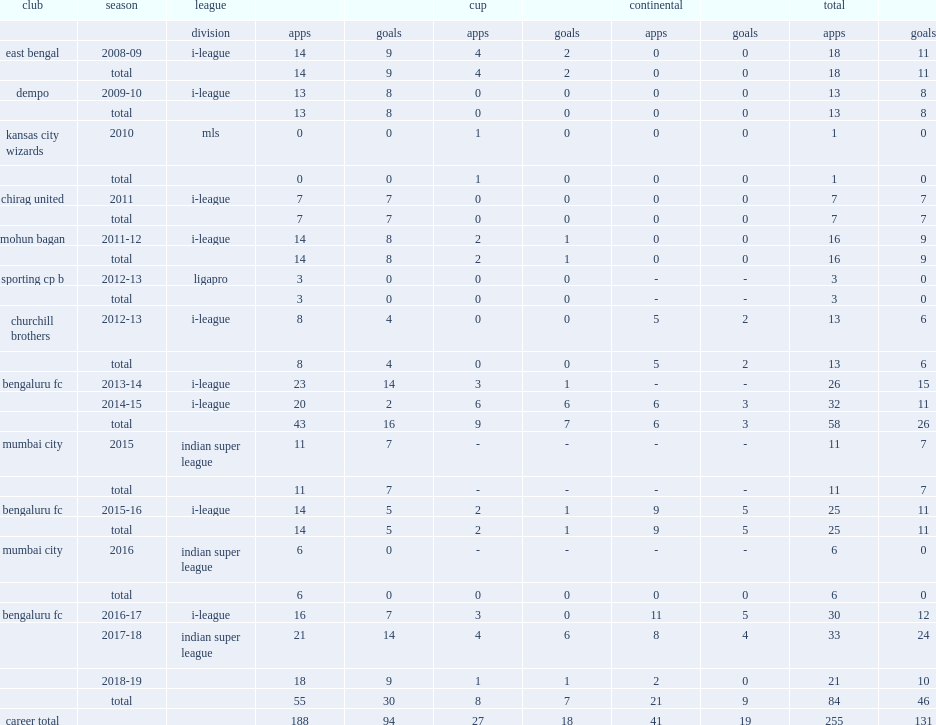When did chhetri move to mumbai city? Indian super league. 